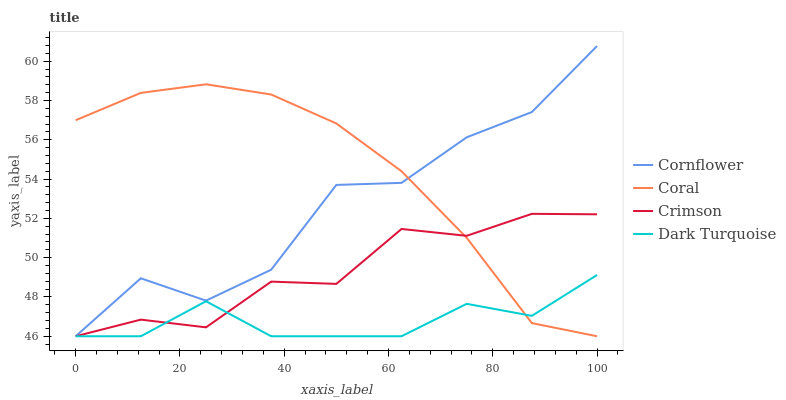Does Dark Turquoise have the minimum area under the curve?
Answer yes or no. Yes. Does Coral have the maximum area under the curve?
Answer yes or no. Yes. Does Cornflower have the minimum area under the curve?
Answer yes or no. No. Does Cornflower have the maximum area under the curve?
Answer yes or no. No. Is Coral the smoothest?
Answer yes or no. Yes. Is Cornflower the roughest?
Answer yes or no. Yes. Is Cornflower the smoothest?
Answer yes or no. No. Is Coral the roughest?
Answer yes or no. No. Does Crimson have the lowest value?
Answer yes or no. Yes. Does Cornflower have the highest value?
Answer yes or no. Yes. Does Coral have the highest value?
Answer yes or no. No. Does Cornflower intersect Coral?
Answer yes or no. Yes. Is Cornflower less than Coral?
Answer yes or no. No. Is Cornflower greater than Coral?
Answer yes or no. No. 